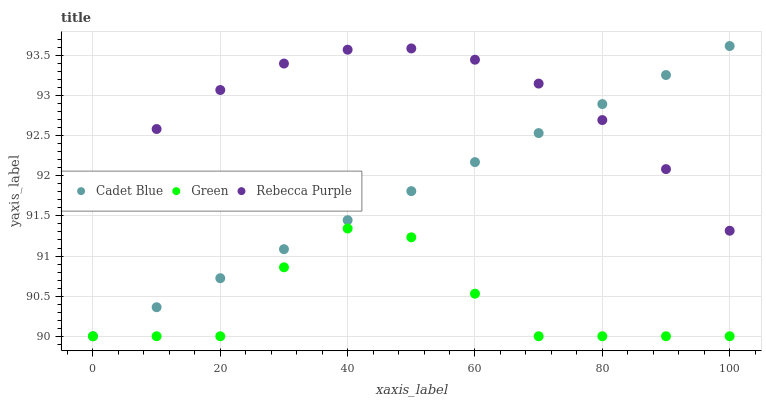Does Green have the minimum area under the curve?
Answer yes or no. Yes. Does Rebecca Purple have the maximum area under the curve?
Answer yes or no. Yes. Does Rebecca Purple have the minimum area under the curve?
Answer yes or no. No. Does Green have the maximum area under the curve?
Answer yes or no. No. Is Cadet Blue the smoothest?
Answer yes or no. Yes. Is Green the roughest?
Answer yes or no. Yes. Is Rebecca Purple the smoothest?
Answer yes or no. No. Is Rebecca Purple the roughest?
Answer yes or no. No. Does Cadet Blue have the lowest value?
Answer yes or no. Yes. Does Rebecca Purple have the lowest value?
Answer yes or no. No. Does Cadet Blue have the highest value?
Answer yes or no. Yes. Does Rebecca Purple have the highest value?
Answer yes or no. No. Is Green less than Rebecca Purple?
Answer yes or no. Yes. Is Rebecca Purple greater than Green?
Answer yes or no. Yes. Does Cadet Blue intersect Rebecca Purple?
Answer yes or no. Yes. Is Cadet Blue less than Rebecca Purple?
Answer yes or no. No. Is Cadet Blue greater than Rebecca Purple?
Answer yes or no. No. Does Green intersect Rebecca Purple?
Answer yes or no. No. 